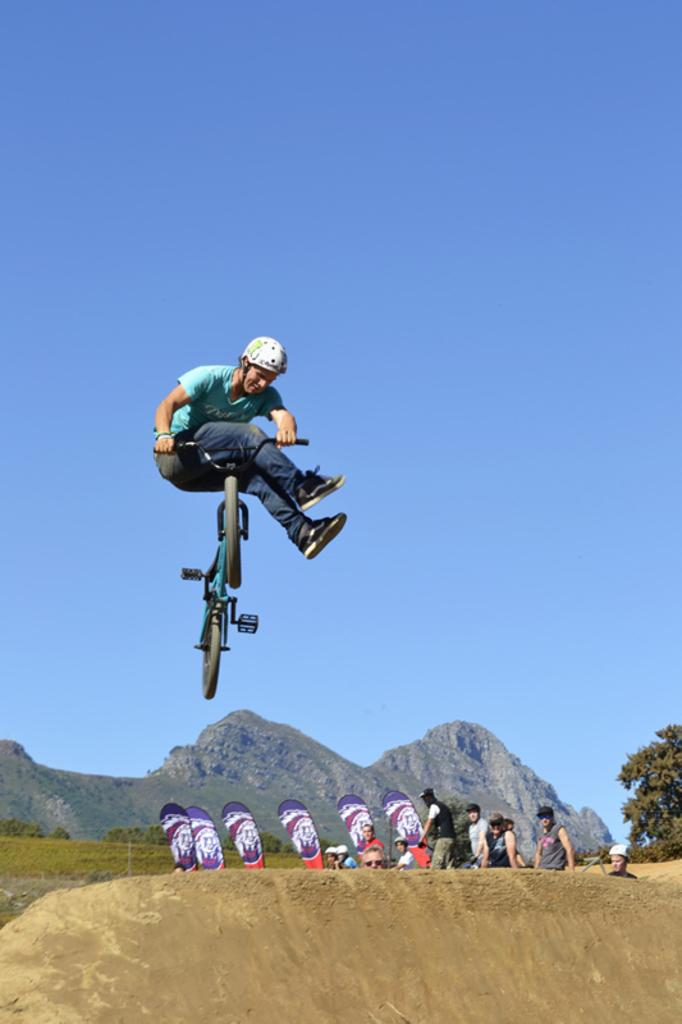What is the man in the image doing? The man is performing stunts with a cycle in the image. What can be seen in the background of the image? There are people, flags, trees, a mountain, and the sky visible in the background of the image. Where is the nail being hammered in the image? There is no nail being hammered in the image. What type of pot is being used to cook food in the image? There is no pot or cooking activity present in the image. 